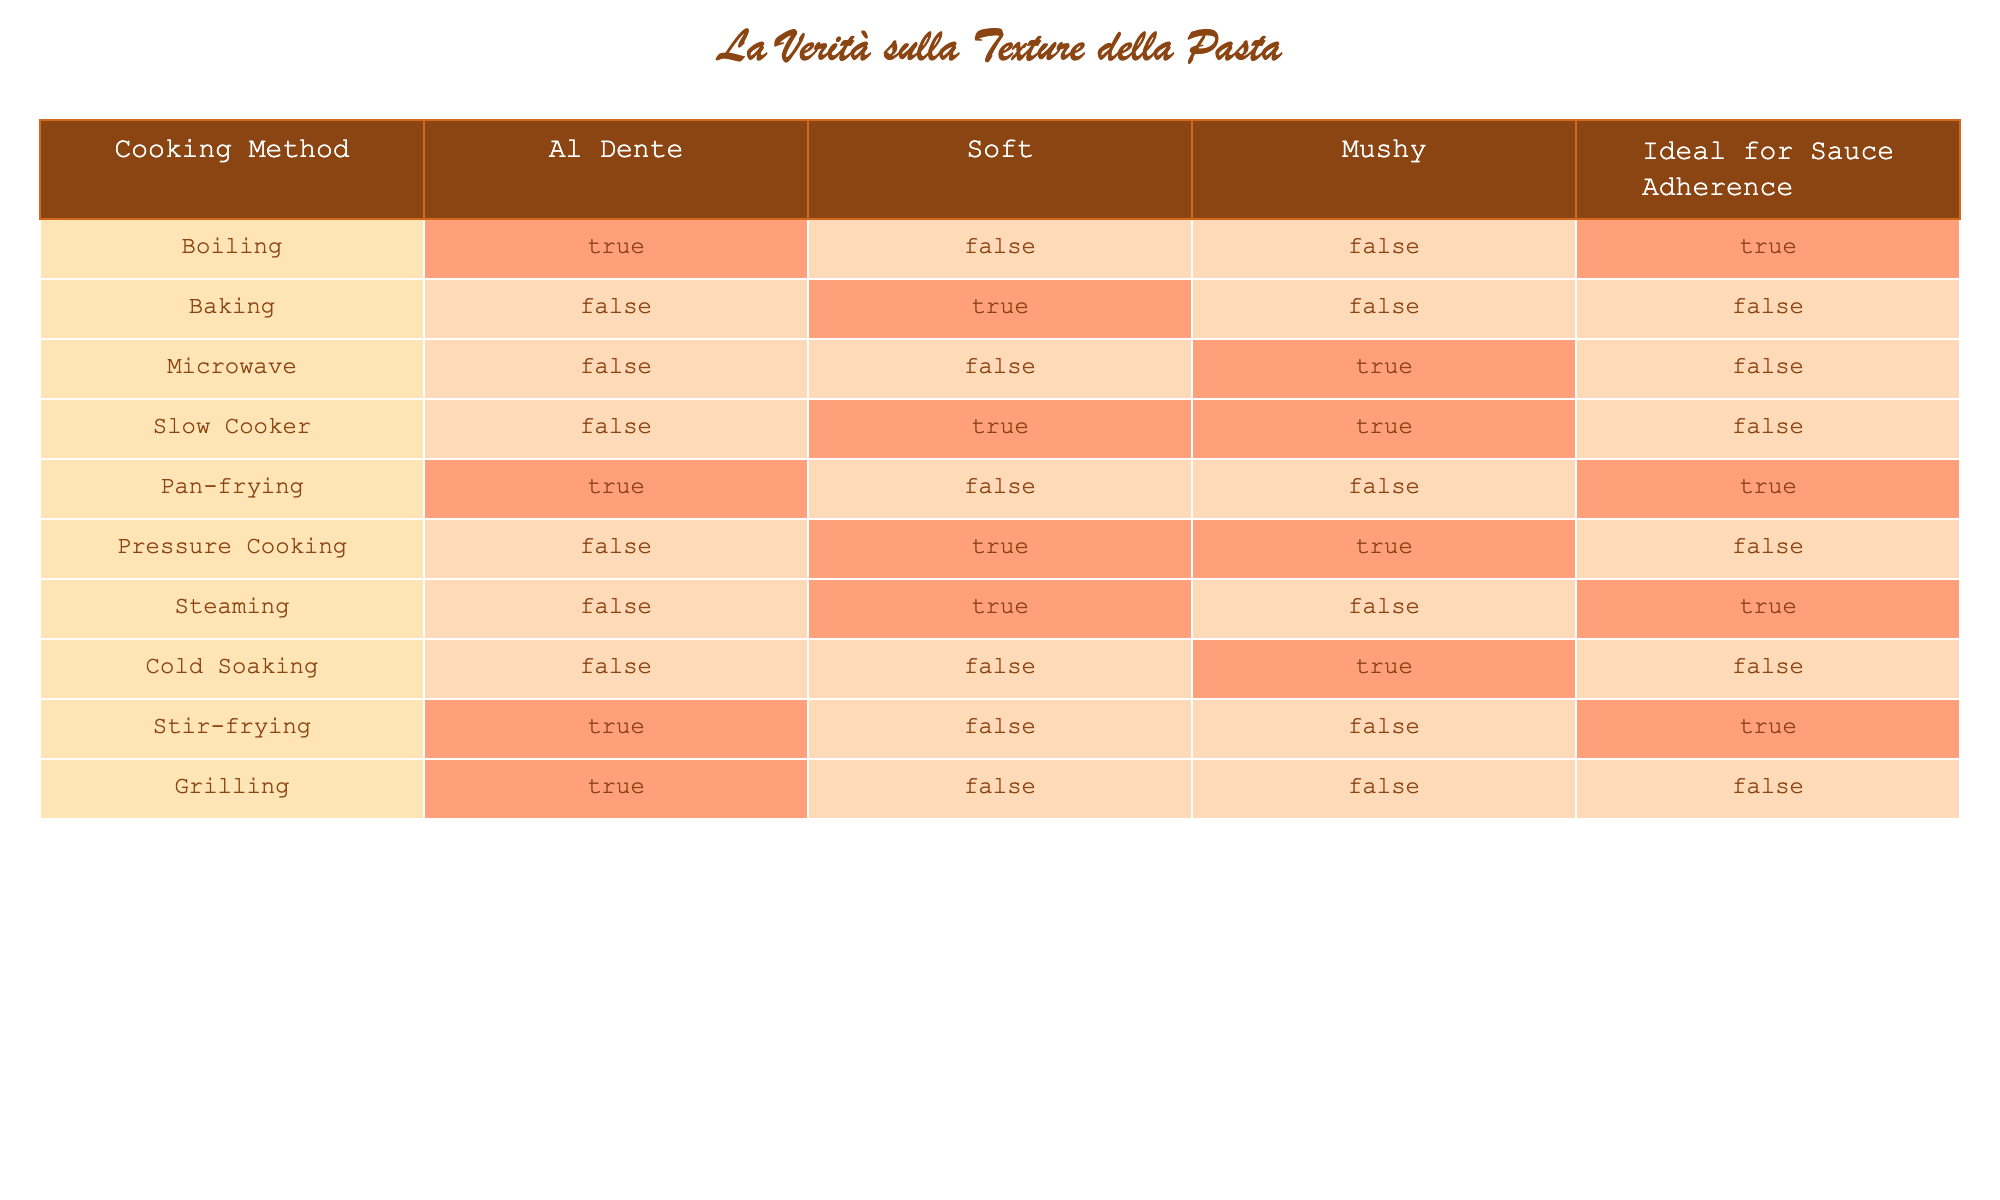What cooking method can achieve the Al Dente texture for pasta? Referring to the table, the cooking methods that allow the pasta to reach an Al Dente texture are Boiling, Pan-frying, and Stir-frying, as they all have "TRUE" in the Al Dente column.
Answer: Boiling, Pan-frying, Stir-frying Is there any cooking method that results in Mushy pasta? Looking at the table, the cooking methods with "TRUE" for the Mushy column are Microwave, Slow Cooker, Pressure Cooking, and Cold Soaking. Thus, these methods lead to a Mushy texture.
Answer: Microwave, Slow Cooker, Pressure Cooking, Cold Soaking How many cooking methods are ideal for Sauce Adherence? To find this, we check the Sauce Adherence column for "TRUE". The methods that fit this criterion are Boiling, Pan-frying, Steaming, and Stir-frying, totaling four methods.
Answer: 4 Which cooking method achieves a Soft texture but is not ideal for Sauce Adherence? By looking at the table, Baking, Slow Cooker, and Pressure Cooking result in a Soft texture but all have "FALSE" in the Sauce Adherence column, making them suitable answers.
Answer: Baking, Slow Cooker, Pressure Cooking How many cooking methods available in the table create both a Soft and Mushy texture? From the table's data, we see that Slow Cooker and Pressure Cooking produce both Soft and Mushy textures, indicated by "TRUE" in both the respective columns.
Answer: 2 Is Grilling suitable for making pasta adherent to sauce? Checking the Sauce Adherence column, Grilling has a "FALSE" value, indicating that it is not suitable for making pasta adhere to sauce.
Answer: No What is the sum of cooking methods that can only make Soft pasta? The table shows three cooking methods (Baking, Slow Cooker, Pressure Cooking) that are dedicated to creating Soft pasta. The sum of methods achieving only Soft texture is 3.
Answer: 3 Which cooking methods should you avoid if you want to ensure your pasta remains Al Dente? The table shows that Baking, Microwave, Slow Cooker, Pressure Cooking, and Grilling do not produce Al Dente pasta as indicated in their respective columns, so these should be avoided for that texture.
Answer: Baking, Microwave, Slow Cooker, Pressure Cooking, Grilling If a cooking method produces Al Dente pasta, what is the likelihood that it will also adhere well to sauce? Examining the methods that yield Al Dente, which are Boiling, Pan-frying, and Stir-frying, we see that Boiling and Pan-frying allow for good sauce adherence (both have "TRUE"). Thus, 2 out of 3 methods adhere to sauce. The probability is therefore approximately 66.67%.
Answer: 66.67% 